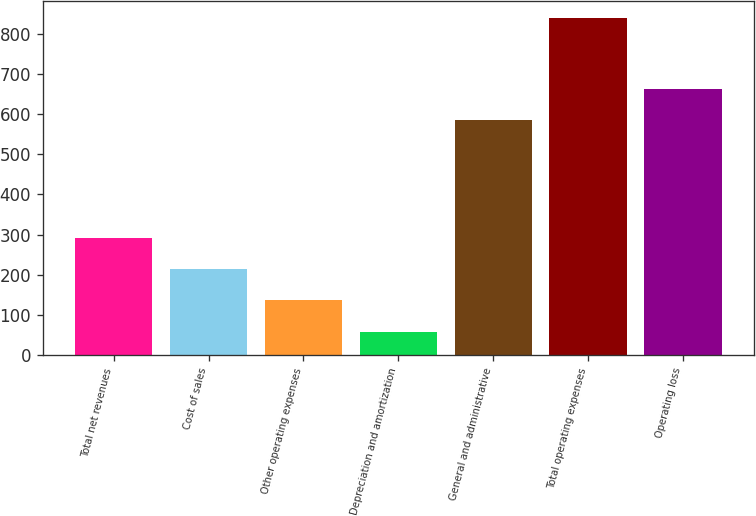Convert chart to OTSL. <chart><loc_0><loc_0><loc_500><loc_500><bar_chart><fcel>Total net revenues<fcel>Cost of sales<fcel>Other operating expenses<fcel>Depreciation and amortization<fcel>General and administrative<fcel>Total operating expenses<fcel>Operating loss<nl><fcel>292.6<fcel>214.6<fcel>136.6<fcel>58.6<fcel>584<fcel>838.6<fcel>662<nl></chart> 